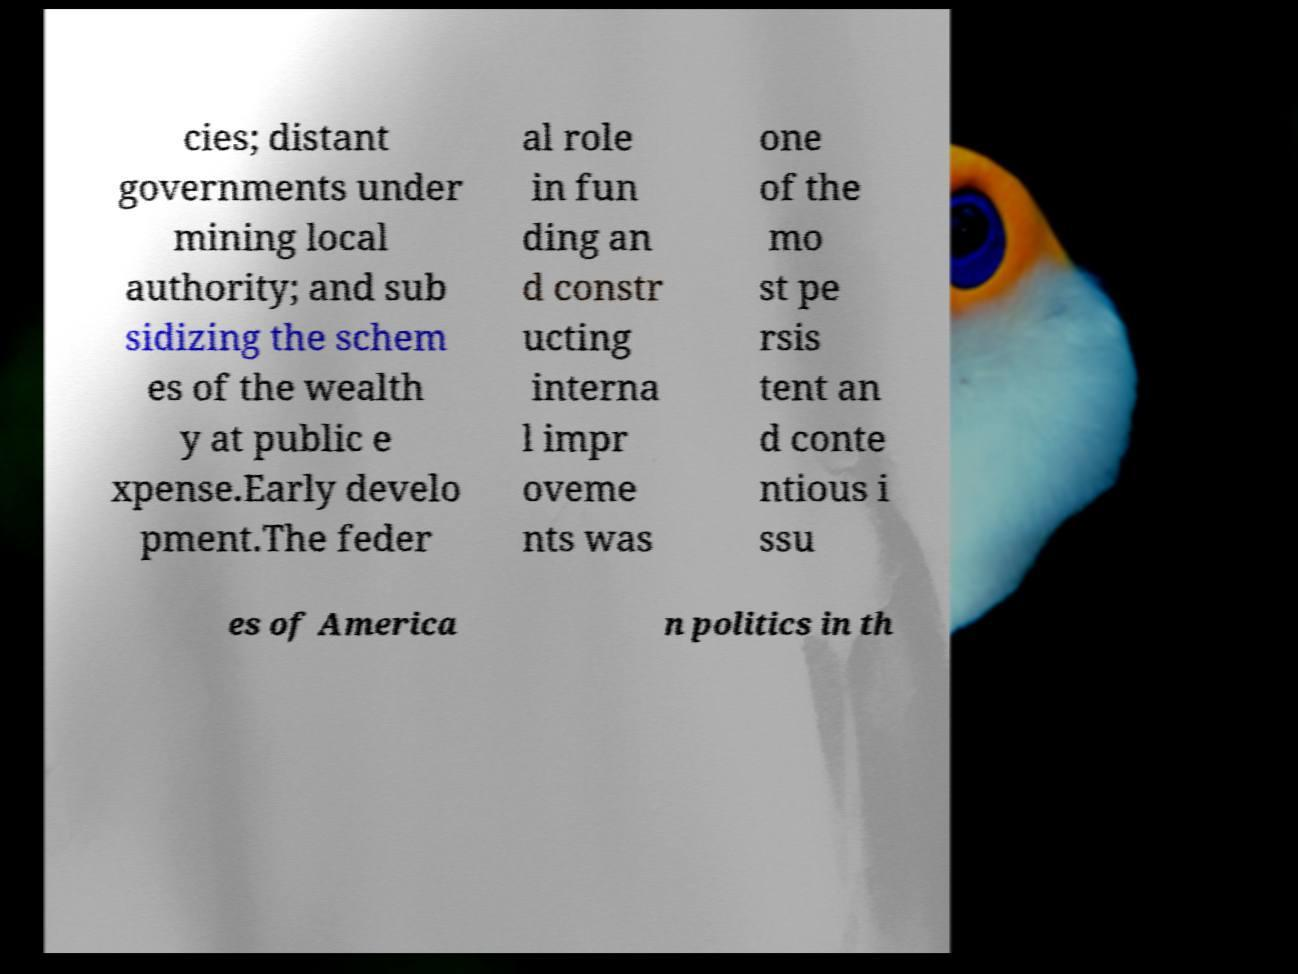Please read and relay the text visible in this image. What does it say? cies; distant governments under mining local authority; and sub sidizing the schem es of the wealth y at public e xpense.Early develo pment.The feder al role in fun ding an d constr ucting interna l impr oveme nts was one of the mo st pe rsis tent an d conte ntious i ssu es of America n politics in th 